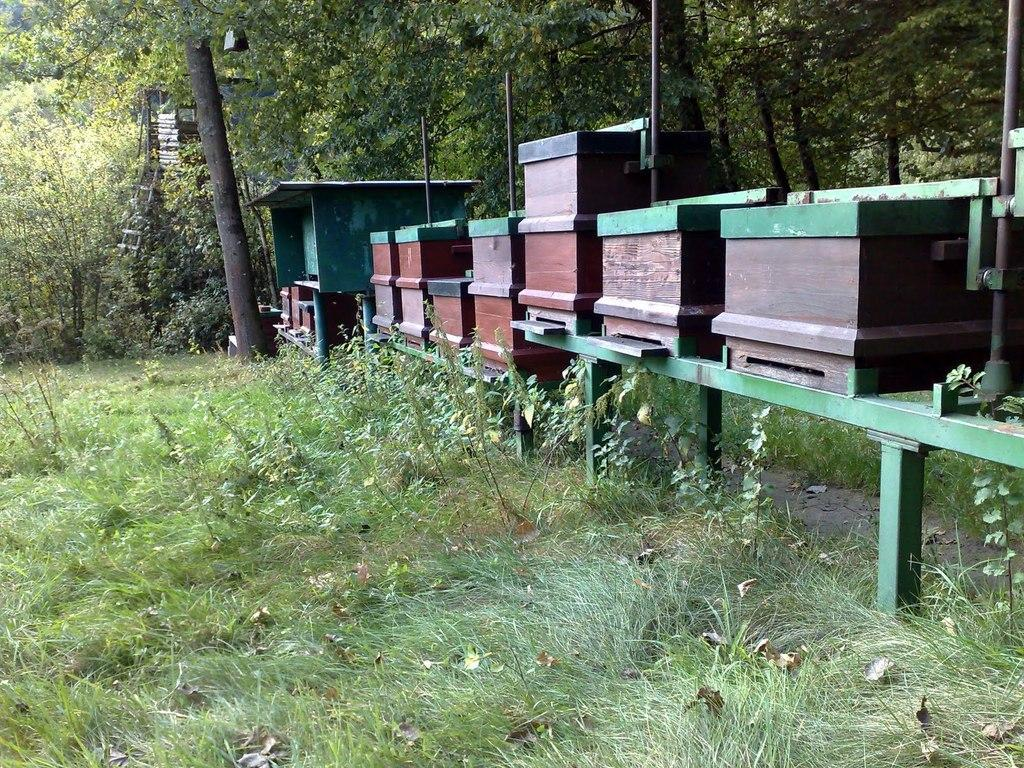What type of objects are in the image? There are wooden boxes in the image. How are the wooden boxes supported? The wooden boxes are on a green iron frame. What is the ground surface like in the image? There is grass on the ground in the image. What can be seen in the distance in the image? There are many trees in the background of the image. Where is the father of the person who took the picture in the image? There is no person or father mentioned in the image, so it cannot be determined where they might be. 